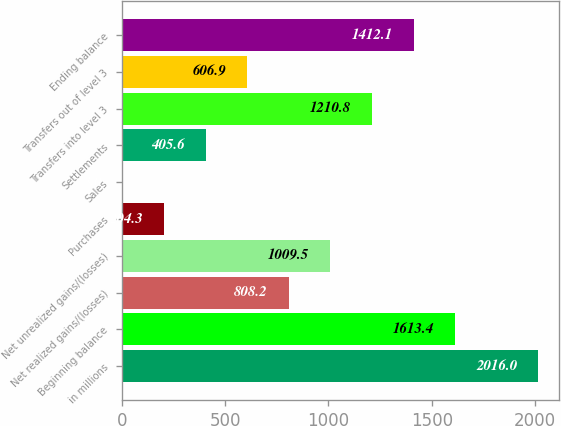Convert chart. <chart><loc_0><loc_0><loc_500><loc_500><bar_chart><fcel>in millions<fcel>Beginning balance<fcel>Net realized gains/(losses)<fcel>Net unrealized gains/(losses)<fcel>Purchases<fcel>Sales<fcel>Settlements<fcel>Transfers into level 3<fcel>Transfers out of level 3<fcel>Ending balance<nl><fcel>2016<fcel>1613.4<fcel>808.2<fcel>1009.5<fcel>204.3<fcel>3<fcel>405.6<fcel>1210.8<fcel>606.9<fcel>1412.1<nl></chart> 